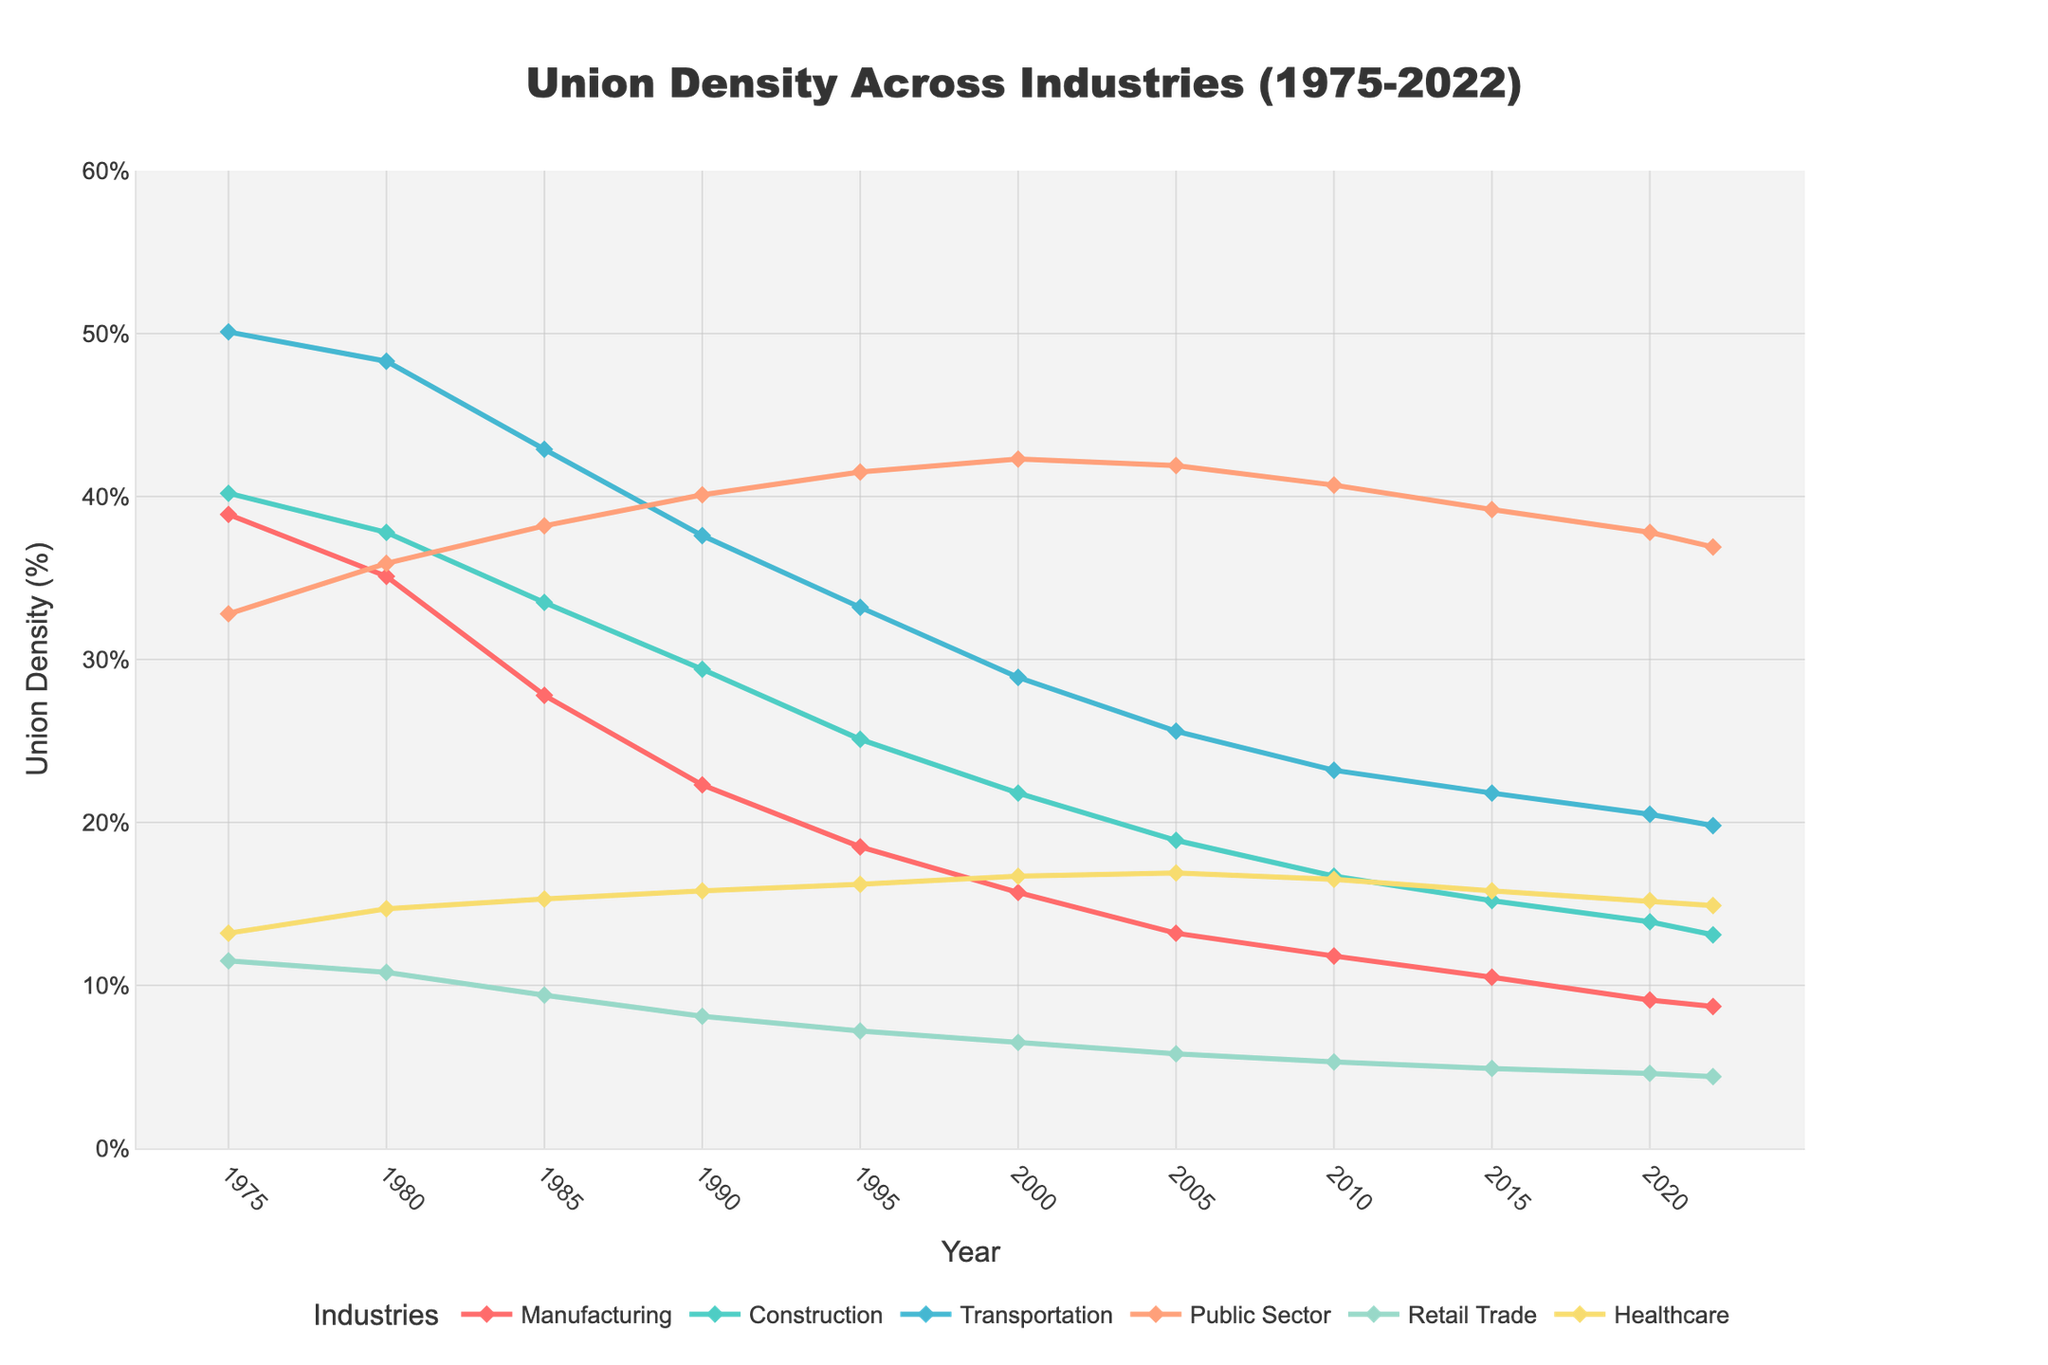What is the overall trend in union density for the Manufacturing industry from 1975 to 2022? From the figure, observe the line representing the Manufacturing industry. Notice that it starts high and gradually decreases over time, indicating a consistent downward trend in union density.
Answer: Downward Comparing 1975 and 2022, which industry had the smallest decrease in union density? Calculate the difference in union density for each industry between these two years and identify the smallest decrease. The Public Sector shows a decrease from 32.8% to 36.9%, which is an increase rather than a decrease. Considering decreases only, Retail Trade changes from 11.5% to 4.4%, a decrease of 7.1%, which is smaller than the changes in Manufacturing (38.9% to 8.7%) and other industries.
Answer: Retail Trade By how many percentage points did union density in the Public Sector increase from 1975 to 2000? Look at the data points for Public Sector in 1975 (32.8%) and 2000 (42.3%). Subtract the 1975 value from the 2000 value: 42.3% - 32.8% = 9.5 percentage points.
Answer: 9.5 percentage points Which industry had the highest union density in 2022, and what was the value? Refer to the 2022 datapoints for all industries and find the highest value. The Public Sector has the highest union density in 2022 with 36.9%.
Answer: Public Sector, 36.9% Between 1980 and 1995, which industry showed the steepest decline in union density? Calculate the change in union density for each industry from 1980 to 1995 and look for the greatest negative change. Manufacturing declines from 35.1% to 18.5%, which is the steepest decline among the industries.
Answer: Manufacturing What was the average union density across all industries in 2010? Add the union densities for all six industries in 2010 and divide by the number of industries: (11.8 + 16.7 + 23.2 + 40.7 + 5.3 + 16.5) / 6 = 19.03%.
Answer: 19.03% In which year did Construction's union density fall below 20% for the first time? Check the data points for Construction across the years and find the first year where the density is below 20%. This occurs in 2000, where the union density is 18.9%.
Answer: 2000 Comparing the trends, did Healthcare or Transportation see a greater decrease in union density between 1975 and 2022? Calculate the change for Healthcare (13.2% to 14.9%) and Transportation (50.1% to 19.8%), and compare the magnitude of the decreases. Transportation saw a greater decrease.
Answer: Transportation Which industry consistently maintained a union density above 40% from 1975 to 2005? Review the union density values for each year from 1975 to 2005. The Public Sector maintained values consistently above 40% during this period.
Answer: Public Sector 